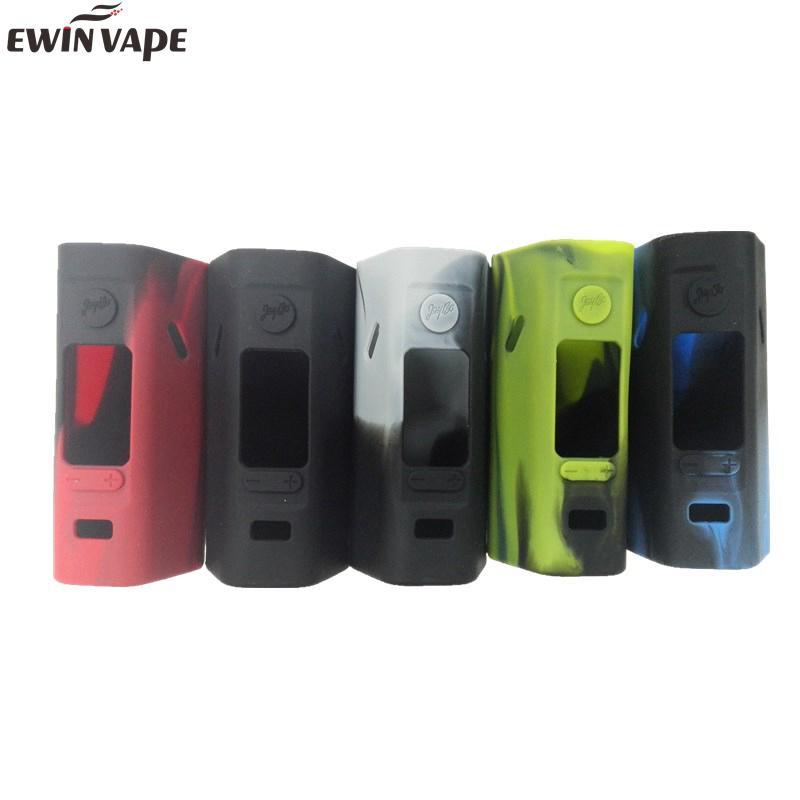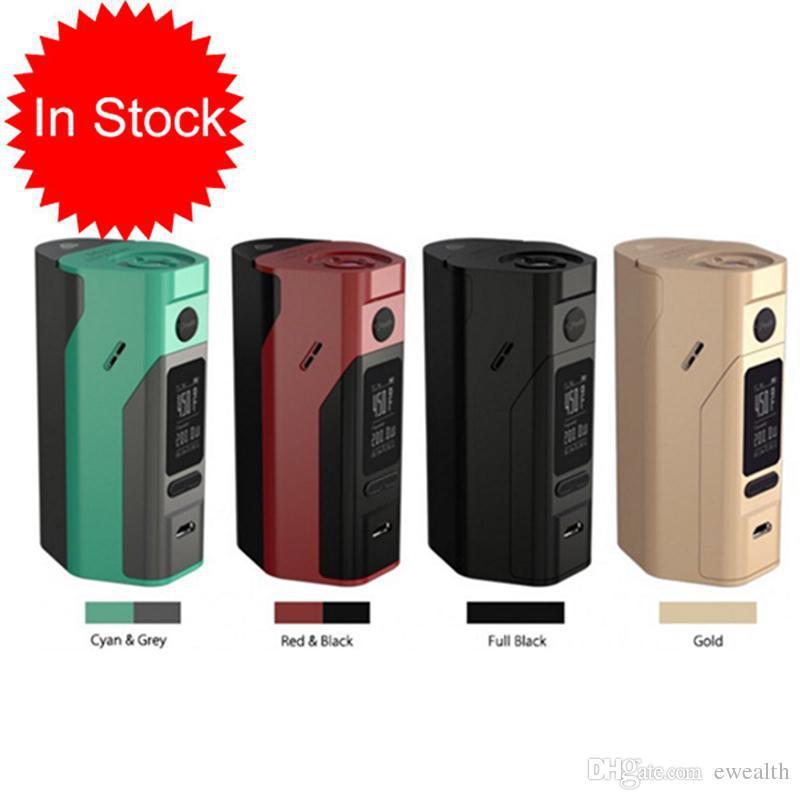The first image is the image on the left, the second image is the image on the right. Assess this claim about the two images: "The right image contains exactly four vape devices.". Correct or not? Answer yes or no. Yes. The first image is the image on the left, the second image is the image on the right. Examine the images to the left and right. Is the description "The same number of phones, each sporting a distinct color design, is in each image." accurate? Answer yes or no. No. 